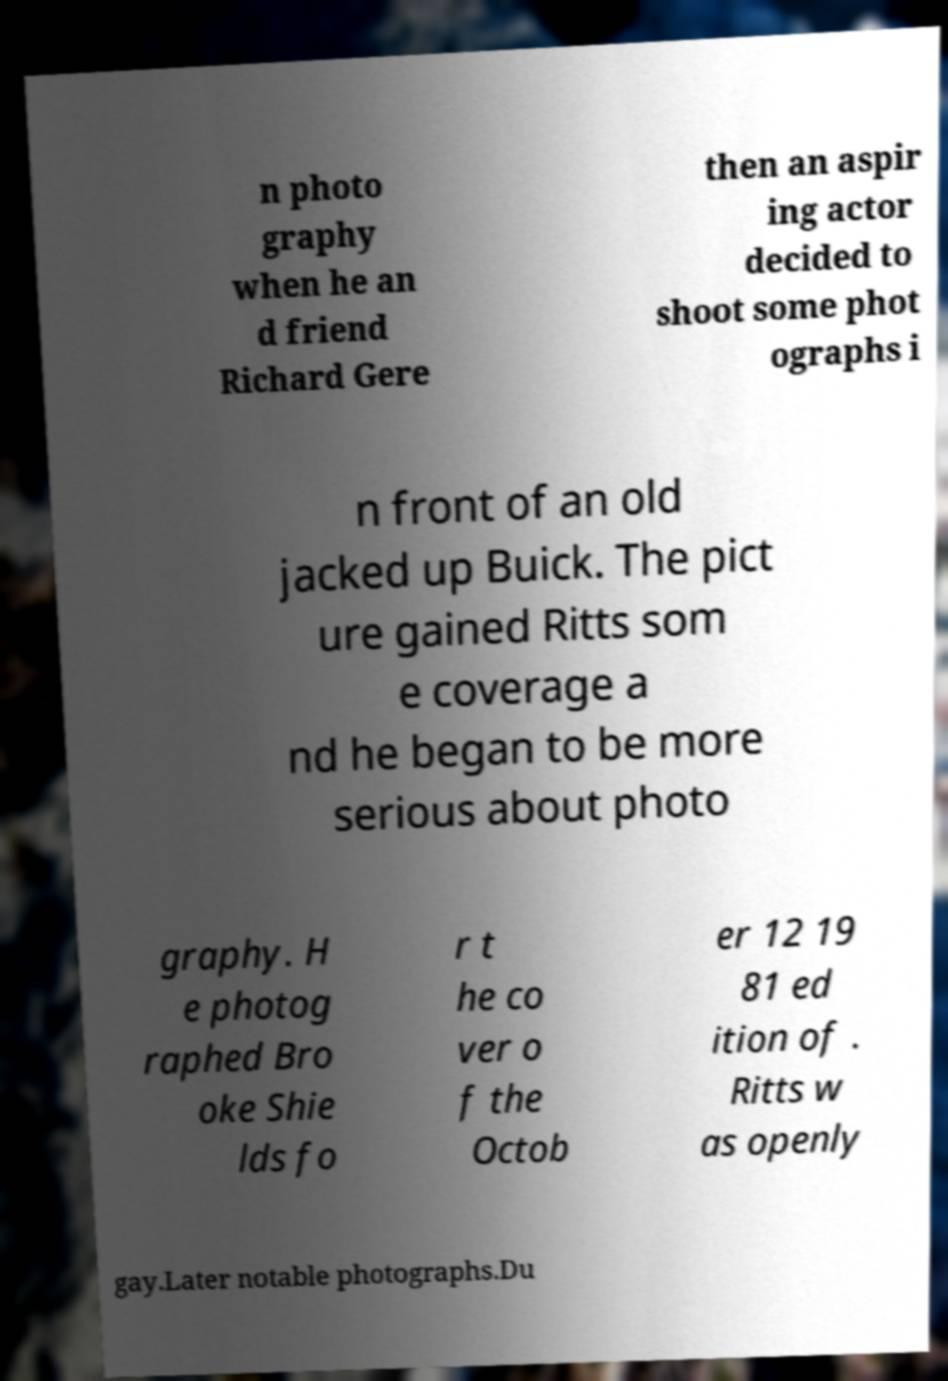Can you accurately transcribe the text from the provided image for me? n photo graphy when he an d friend Richard Gere then an aspir ing actor decided to shoot some phot ographs i n front of an old jacked up Buick. The pict ure gained Ritts som e coverage a nd he began to be more serious about photo graphy. H e photog raphed Bro oke Shie lds fo r t he co ver o f the Octob er 12 19 81 ed ition of . Ritts w as openly gay.Later notable photographs.Du 